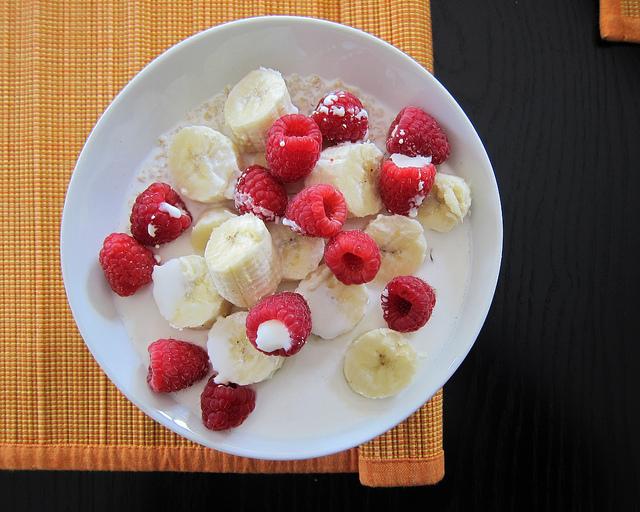What is under the plate?
Quick response, please. Placemat. How many strawberries are seen?
Short answer required. 0. What color is the raspberries?
Give a very brief answer. Red. 